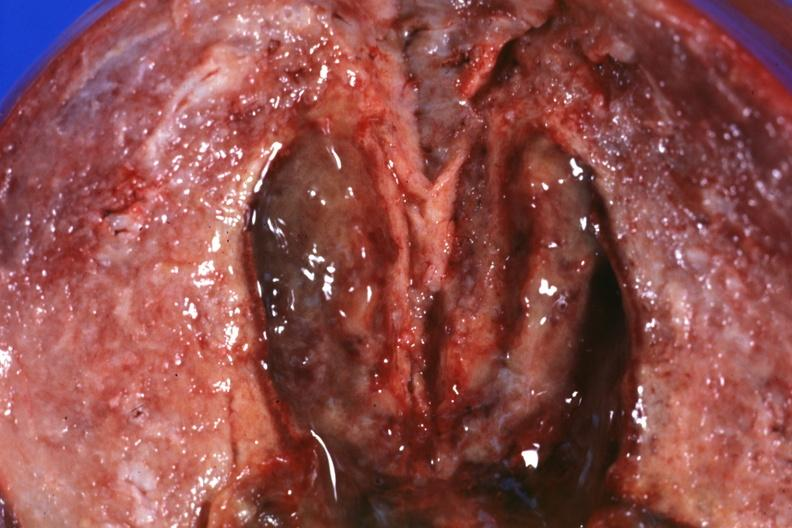what is present?
Answer the question using a single word or phrase. Female reproductive 